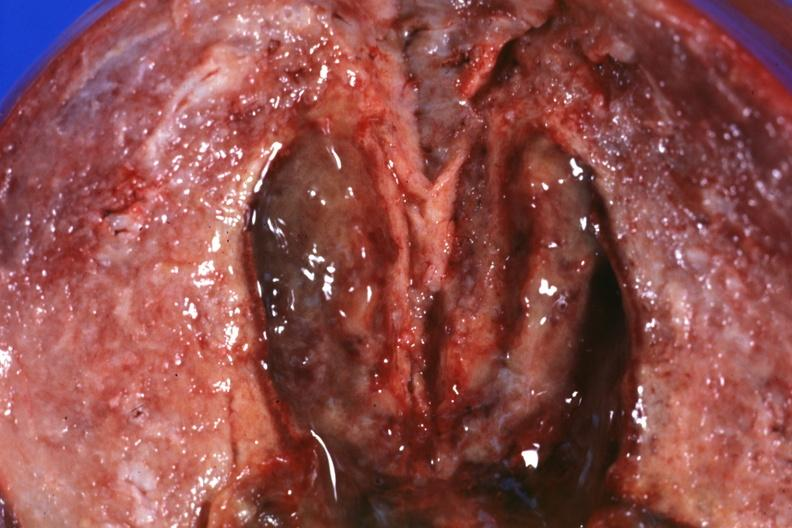what is present?
Answer the question using a single word or phrase. Female reproductive 